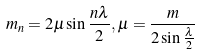Convert formula to latex. <formula><loc_0><loc_0><loc_500><loc_500>m _ { n } = 2 \mu \sin \frac { n \lambda } { 2 } , \mu = \frac { m } { 2 \sin \frac { \lambda } { 2 } }</formula> 